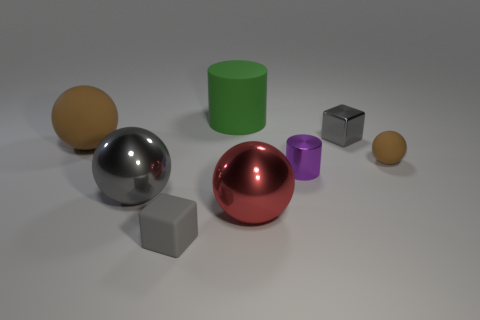What is the shape of the small brown matte thing?
Your answer should be compact. Sphere. There is a small gray object that is behind the cube that is in front of the small gray shiny cube; how many gray metallic objects are in front of it?
Provide a succinct answer. 1. The large rubber thing that is the same shape as the purple metal object is what color?
Offer a terse response. Green. What is the shape of the tiny object that is on the right side of the metallic cube that is behind the metal object that is left of the matte cube?
Give a very brief answer. Sphere. There is a shiny thing that is both behind the big gray sphere and in front of the tiny shiny block; what size is it?
Offer a very short reply. Small. Is the number of gray matte things less than the number of small purple matte objects?
Offer a very short reply. No. What is the size of the rubber ball to the left of the big green cylinder?
Your response must be concise. Large. There is a gray thing that is right of the big gray metallic sphere and in front of the tiny brown sphere; what is its shape?
Offer a very short reply. Cube. The other brown thing that is the same shape as the big brown rubber object is what size?
Provide a succinct answer. Small. How many other gray objects are made of the same material as the large gray thing?
Provide a succinct answer. 1. 